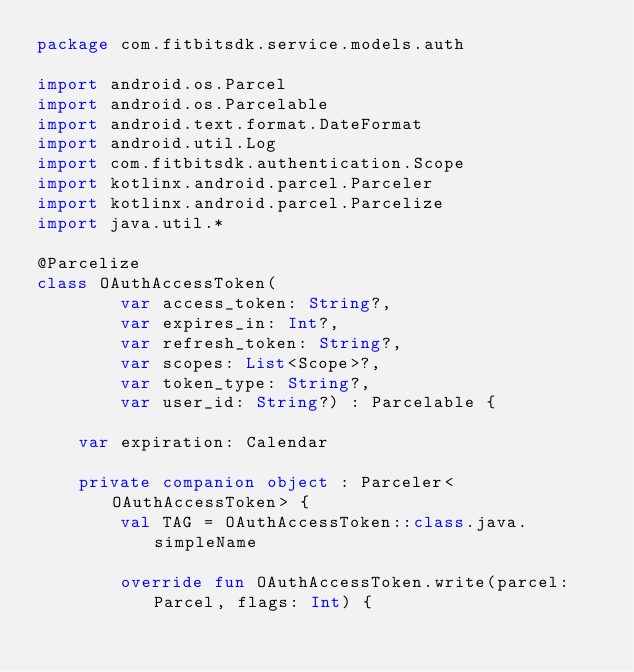Convert code to text. <code><loc_0><loc_0><loc_500><loc_500><_Kotlin_>package com.fitbitsdk.service.models.auth

import android.os.Parcel
import android.os.Parcelable
import android.text.format.DateFormat
import android.util.Log
import com.fitbitsdk.authentication.Scope
import kotlinx.android.parcel.Parceler
import kotlinx.android.parcel.Parcelize
import java.util.*

@Parcelize
class OAuthAccessToken(
        var access_token: String?,
        var expires_in: Int?,
        var refresh_token: String?,
        var scopes: List<Scope>?,
        var token_type: String?,
        var user_id: String?) : Parcelable {

    var expiration: Calendar

    private companion object : Parceler<OAuthAccessToken> {
        val TAG = OAuthAccessToken::class.java.simpleName

        override fun OAuthAccessToken.write(parcel: Parcel, flags: Int) {</code> 